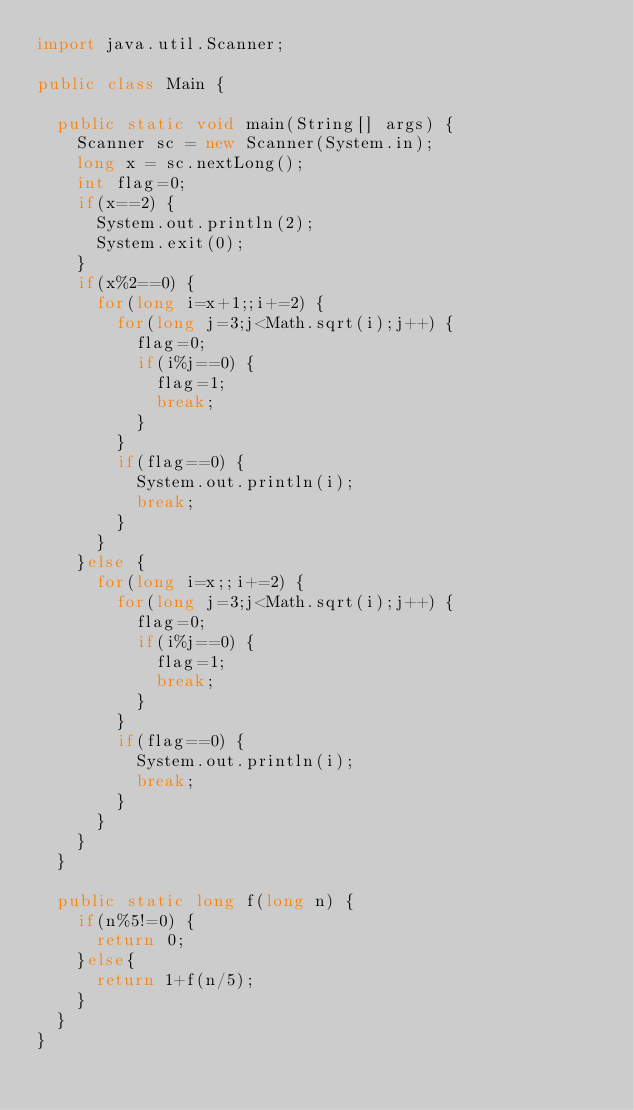<code> <loc_0><loc_0><loc_500><loc_500><_Java_>import java.util.Scanner;

public class Main {

	public static void main(String[] args) {
		Scanner sc = new Scanner(System.in);
		long x = sc.nextLong();
		int flag=0;
		if(x==2) {
			System.out.println(2);
			System.exit(0);
		}
		if(x%2==0) {
			for(long i=x+1;;i+=2) {
				for(long j=3;j<Math.sqrt(i);j++) {
					flag=0;
					if(i%j==0) {
						flag=1;
						break;
					}
				}
				if(flag==0) {
					System.out.println(i);
					break;
				}
			}
		}else {
			for(long i=x;;i+=2) {
				for(long j=3;j<Math.sqrt(i);j++) {
					flag=0;
					if(i%j==0) {
						flag=1;
						break;
					}
				}
				if(flag==0) {
					System.out.println(i);
					break;
				}
			}
		}
	}

	public static long f(long n) {
		if(n%5!=0) {
			return 0;
		}else{
			return 1+f(n/5);
		}
	}
}


</code> 